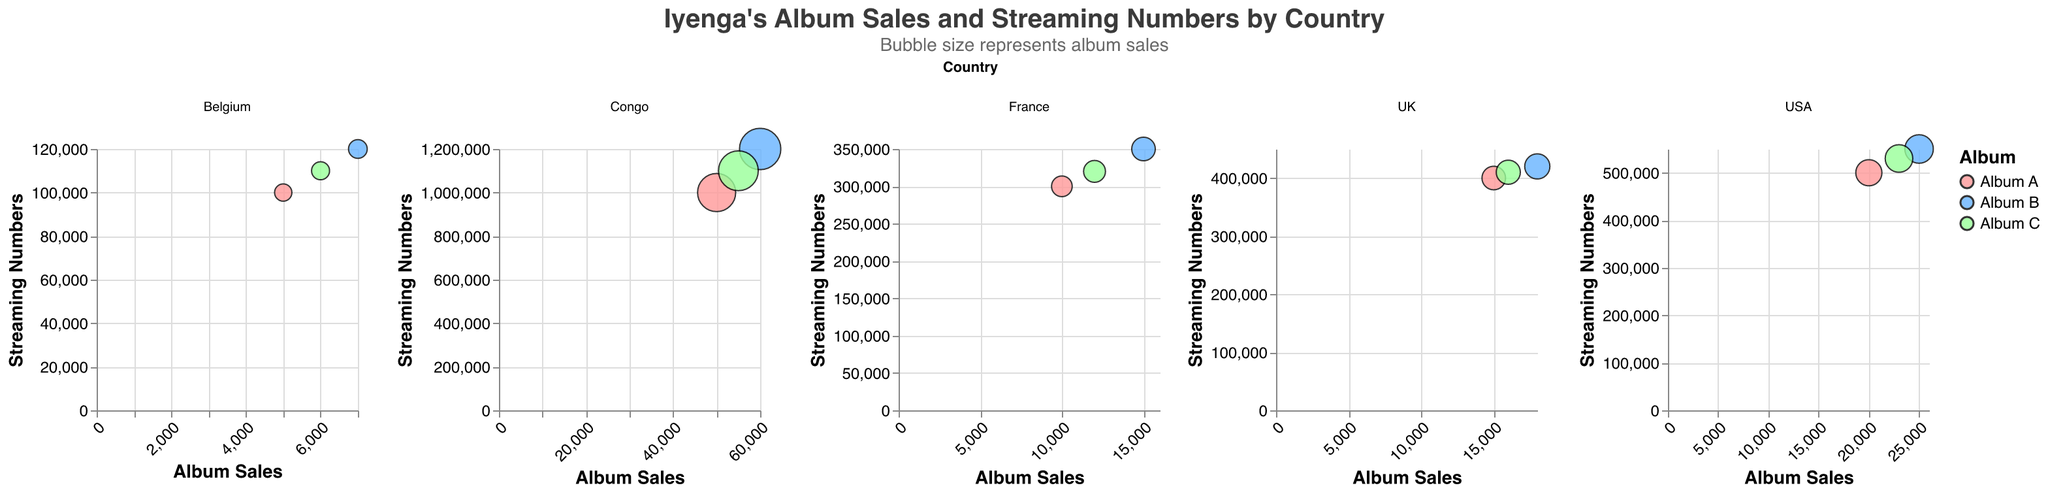How many countries' data are shown in the figure? The figure faceted by the 'country' column shows individual plots for each country. By counting these facets, we can determine the number of countries.
Answer: 5 What are the colors representing each album? The figure uses colors to distinguish between Album A, Album B, and Album C. The legend indicates that Album A is red, Album B is blue, and Album C is green.
Answer: Album A: red, Album B: blue, Album C: green Which country has the highest album sales for any single album? Check the x-axis values for all countries and identify the largest value. Congo has the highest value with Album B at 60,000 sales.
Answer: Congo What is the total number of album sales for Album A in all countries? Find the sales values for Album A in each country and sum them: 50,000 (Congo) + 10,000 (France) + 5,000 (Belgium) + 20,000 (USA) + 15,000 (UK) = 100,000
Answer: 100,000 How do the streaming numbers for Album B in the USA compare to Album B in the UK? Checking the y-axis values, Album B in the USA has 550,000 streams, and Album B in the UK has 420,000 streams. The USA has 130,000 more streams.
Answer: The USA has 130,000 more streams Which album has the largest bubble in the figure? The bubble size represents sales. Identify the largest bubble by its visual size; Album B in Congo has the largest bubble at 60,000 sales.
Answer: Album B in Congo Does Album C have higher sales in France or Belgium? Compare the x-axis values for Album C in France (12,000) and Belgium (6,000). France has higher sales.
Answer: France What is the average number of streams for Album C across all countries? Find the streaming numbers for Album C in each country and compute the average: (1,100,000 + 320,000 + 110,000 + 530,000 + 410,000) / 5 = 494,000
Answer: 494,000 Which album has the least streaming numbers in Belgium? Compare the y-axis values for all albums in Belgium. Album A has the least with 100,000 streams.
Answer: Album A What is the subtitle of the figure? The subtitle can be found just below the title, indicating the bubble size relevance.
Answer: "Bubble size represents album sales" 